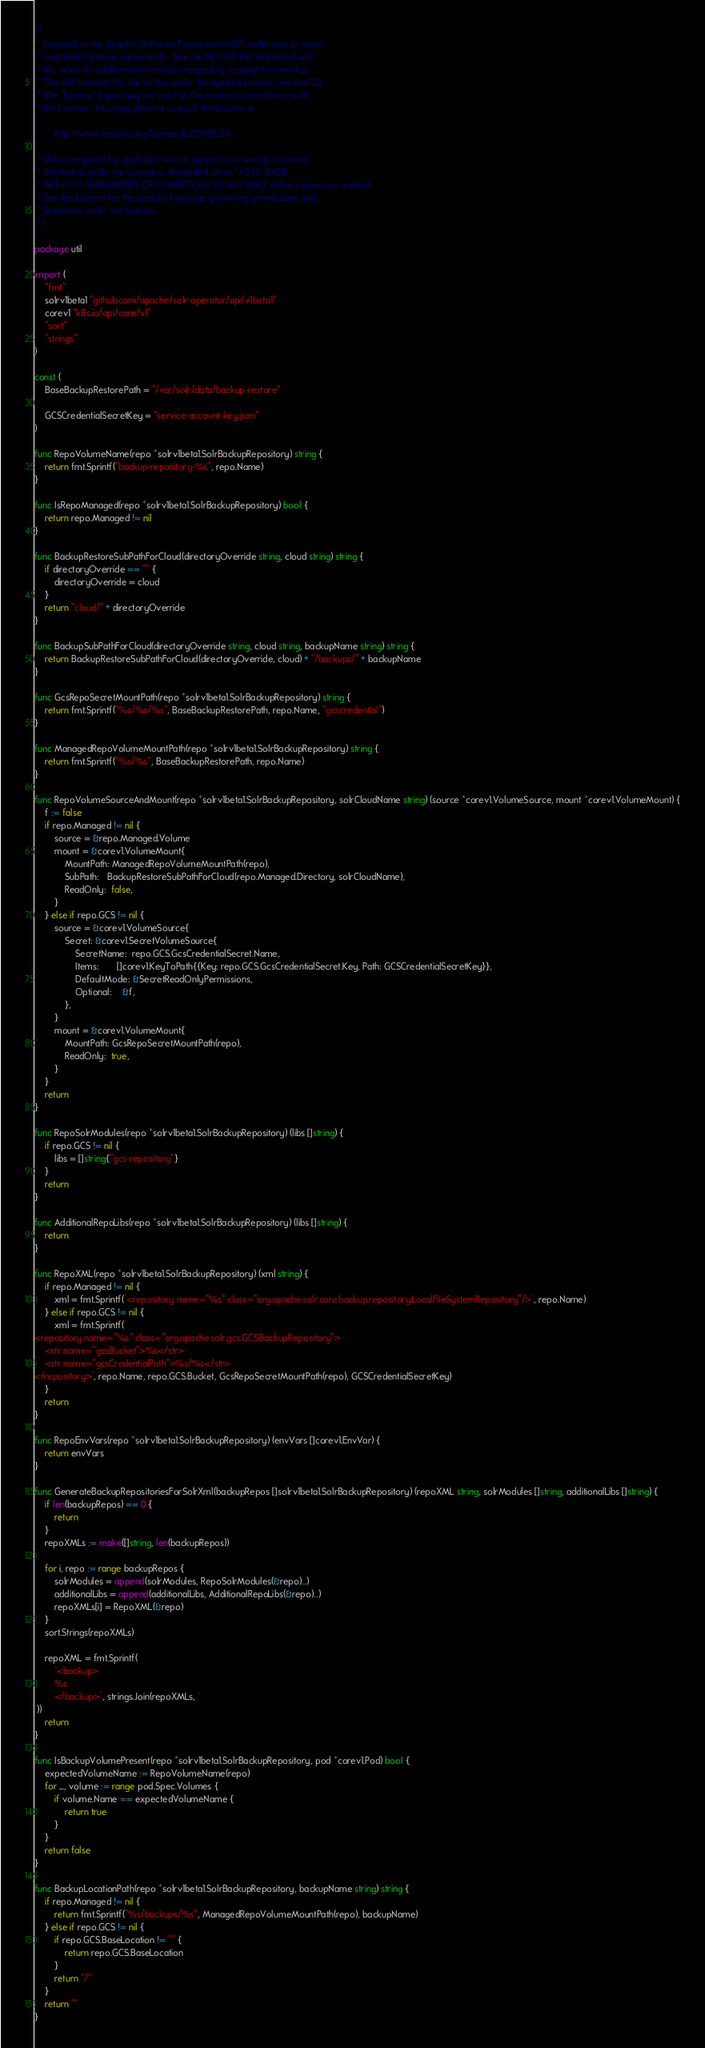Convert code to text. <code><loc_0><loc_0><loc_500><loc_500><_Go_>/*
 * Licensed to the Apache Software Foundation (ASF) under one or more
 * contributor license agreements.  See the NOTICE file distributed with
 * this work for additional information regarding copyright ownership.
 * The ASF licenses this file to You under the Apache License, Version 2.0
 * (the "License"); you may not use this file except in compliance with
 * the License.  You may obtain a copy of the License at
 *
 *     http://www.apache.org/licenses/LICENSE-2.0
 *
 * Unless required by applicable law or agreed to in writing, software
 * distributed under the License is distributed on an "AS IS" BASIS,
 * WITHOUT WARRANTIES OR CONDITIONS OF ANY KIND, either express or implied.
 * See the License for the specific language governing permissions and
 * limitations under the License.
 */

package util

import (
	"fmt"
	solrv1beta1 "github.com/apache/solr-operator/api/v1beta1"
	corev1 "k8s.io/api/core/v1"
	"sort"
	"strings"
)

const (
	BaseBackupRestorePath = "/var/solr/data/backup-restore"

	GCSCredentialSecretKey = "service-account-key.json"
)

func RepoVolumeName(repo *solrv1beta1.SolrBackupRepository) string {
	return fmt.Sprintf("backup-repository-%s", repo.Name)
}

func IsRepoManaged(repo *solrv1beta1.SolrBackupRepository) bool {
	return repo.Managed != nil
}

func BackupRestoreSubPathForCloud(directoryOverride string, cloud string) string {
	if directoryOverride == "" {
		directoryOverride = cloud
	}
	return "cloud/" + directoryOverride
}

func BackupSubPathForCloud(directoryOverride string, cloud string, backupName string) string {
	return BackupRestoreSubPathForCloud(directoryOverride, cloud) + "/backups/" + backupName
}

func GcsRepoSecretMountPath(repo *solrv1beta1.SolrBackupRepository) string {
	return fmt.Sprintf("%s/%s/%s", BaseBackupRestorePath, repo.Name, "gcscredential")
}

func ManagedRepoVolumeMountPath(repo *solrv1beta1.SolrBackupRepository) string {
	return fmt.Sprintf("%s/%s", BaseBackupRestorePath, repo.Name)
}

func RepoVolumeSourceAndMount(repo *solrv1beta1.SolrBackupRepository, solrCloudName string) (source *corev1.VolumeSource, mount *corev1.VolumeMount) {
	f := false
	if repo.Managed != nil {
		source = &repo.Managed.Volume
		mount = &corev1.VolumeMount{
			MountPath: ManagedRepoVolumeMountPath(repo),
			SubPath:   BackupRestoreSubPathForCloud(repo.Managed.Directory, solrCloudName),
			ReadOnly:  false,
		}
	} else if repo.GCS != nil {
		source = &corev1.VolumeSource{
			Secret: &corev1.SecretVolumeSource{
				SecretName:  repo.GCS.GcsCredentialSecret.Name,
				Items:       []corev1.KeyToPath{{Key: repo.GCS.GcsCredentialSecret.Key, Path: GCSCredentialSecretKey}},
				DefaultMode: &SecretReadOnlyPermissions,
				Optional:    &f,
			},
		}
		mount = &corev1.VolumeMount{
			MountPath: GcsRepoSecretMountPath(repo),
			ReadOnly:  true,
		}
	}
	return
}

func RepoSolrModules(repo *solrv1beta1.SolrBackupRepository) (libs []string) {
	if repo.GCS != nil {
		libs = []string{"gcs-repository"}
	}
	return
}

func AdditionalRepoLibs(repo *solrv1beta1.SolrBackupRepository) (libs []string) {
	return
}

func RepoXML(repo *solrv1beta1.SolrBackupRepository) (xml string) {
	if repo.Managed != nil {
		xml = fmt.Sprintf(`<repository name="%s" class="org.apache.solr.core.backup.repository.LocalFileSystemRepository"/>`, repo.Name)
	} else if repo.GCS != nil {
		xml = fmt.Sprintf(`
<repository name="%s" class="org.apache.solr.gcs.GCSBackupRepository">
    <str name="gcsBucket">%s</str>
    <str name="gcsCredentialPath">%s/%s</str>
</repository>`, repo.Name, repo.GCS.Bucket, GcsRepoSecretMountPath(repo), GCSCredentialSecretKey)
	}
	return
}

func RepoEnvVars(repo *solrv1beta1.SolrBackupRepository) (envVars []corev1.EnvVar) {
	return envVars
}

func GenerateBackupRepositoriesForSolrXml(backupRepos []solrv1beta1.SolrBackupRepository) (repoXML string, solrModules []string, additionalLibs []string) {
	if len(backupRepos) == 0 {
		return
	}
	repoXMLs := make([]string, len(backupRepos))

	for i, repo := range backupRepos {
		solrModules = append(solrModules, RepoSolrModules(&repo)...)
		additionalLibs = append(additionalLibs, AdditionalRepoLibs(&repo)...)
		repoXMLs[i] = RepoXML(&repo)
	}
	sort.Strings(repoXMLs)

	repoXML = fmt.Sprintf(
		`<backup>
		%s
		</backup>`, strings.Join(repoXMLs, `
`))
	return
}

func IsBackupVolumePresent(repo *solrv1beta1.SolrBackupRepository, pod *corev1.Pod) bool {
	expectedVolumeName := RepoVolumeName(repo)
	for _, volume := range pod.Spec.Volumes {
		if volume.Name == expectedVolumeName {
			return true
		}
	}
	return false
}

func BackupLocationPath(repo *solrv1beta1.SolrBackupRepository, backupName string) string {
	if repo.Managed != nil {
		return fmt.Sprintf("%s/backups/%s", ManagedRepoVolumeMountPath(repo), backupName)
	} else if repo.GCS != nil {
		if repo.GCS.BaseLocation != "" {
			return repo.GCS.BaseLocation
		}
		return "/"
	}
	return ""
}
</code> 